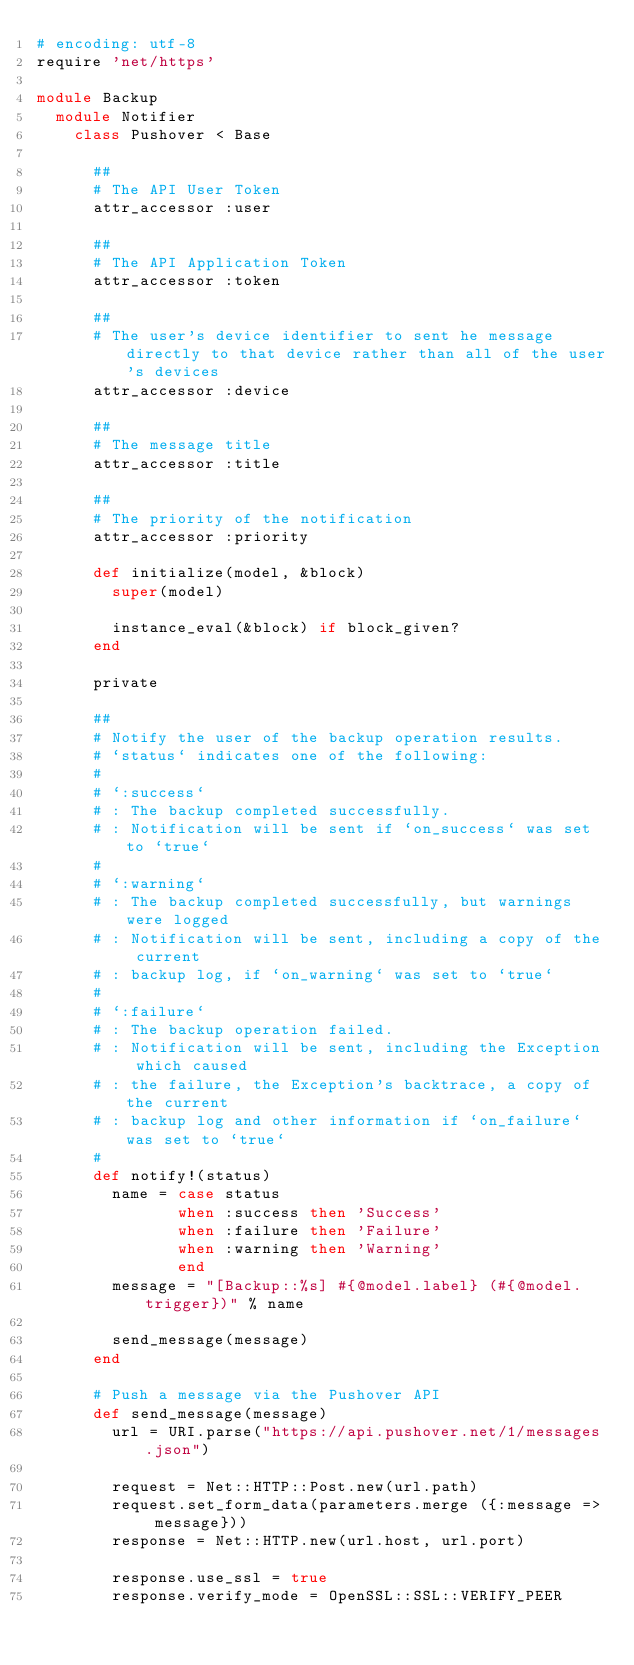Convert code to text. <code><loc_0><loc_0><loc_500><loc_500><_Ruby_># encoding: utf-8
require 'net/https'

module Backup
  module Notifier
    class Pushover < Base

      ##
      # The API User Token
      attr_accessor :user

      ##
      # The API Application Token
      attr_accessor :token

      ##
      # The user's device identifier to sent he message directly to that device rather than all of the user's devices
      attr_accessor :device

      ##
      # The message title
      attr_accessor :title

      ##
      # The priority of the notification
      attr_accessor :priority

      def initialize(model, &block)
        super(model)

        instance_eval(&block) if block_given?
      end

      private

      ##
      # Notify the user of the backup operation results.
      # `status` indicates one of the following:
      #
      # `:success`
      # : The backup completed successfully.
      # : Notification will be sent if `on_success` was set to `true`
      #
      # `:warning`
      # : The backup completed successfully, but warnings were logged
      # : Notification will be sent, including a copy of the current
      # : backup log, if `on_warning` was set to `true`
      #
      # `:failure`
      # : The backup operation failed.
      # : Notification will be sent, including the Exception which caused
      # : the failure, the Exception's backtrace, a copy of the current
      # : backup log and other information if `on_failure` was set to `true`
      #
      def notify!(status)
        name = case status
               when :success then 'Success'
               when :failure then 'Failure'
               when :warning then 'Warning'
               end
        message = "[Backup::%s] #{@model.label} (#{@model.trigger})" % name

        send_message(message)
      end

      # Push a message via the Pushover API
      def send_message(message)
        url = URI.parse("https://api.pushover.net/1/messages.json")

        request = Net::HTTP::Post.new(url.path)
        request.set_form_data(parameters.merge ({:message => message}))
        response = Net::HTTP.new(url.host, url.port)

        response.use_ssl = true
        response.verify_mode = OpenSSL::SSL::VERIFY_PEER
</code> 